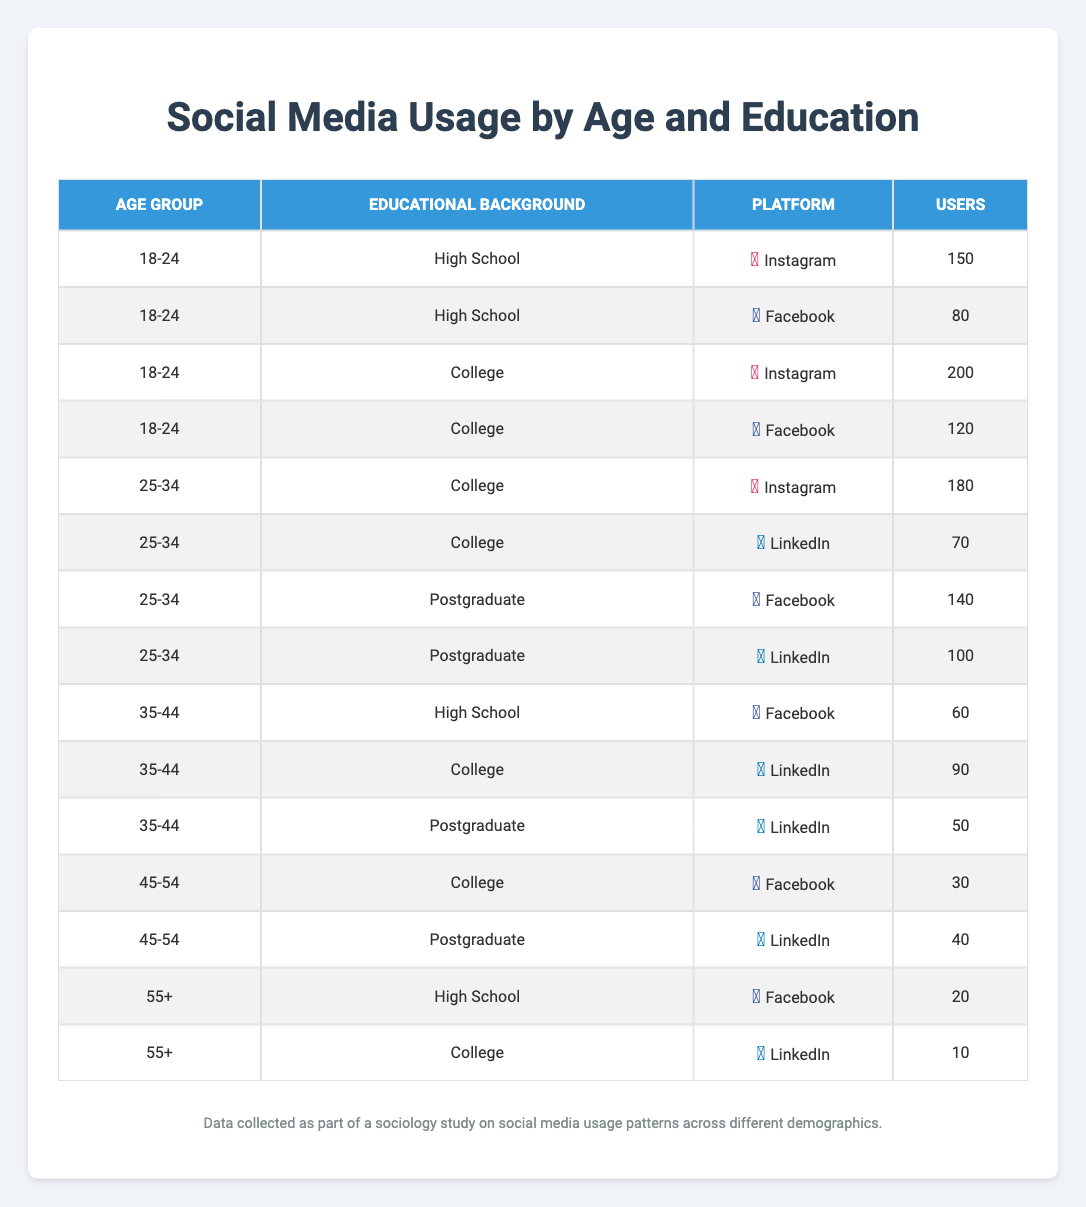What is the number of users aged 25-34 with a College education using Instagram? According to the table, there is a specific entry for the Age Group "25-34" and Educational Background "College" under the Instagram platform. The number of users in that row is 180.
Answer: 180 Which social media platform has the highest number of users in the age group 18-24 with a College education? In the table, for the Age Group "18-24" and Educational Background "College," two platforms are listed: Instagram with 200 users and Facebook with 120 users. Instagram has the highest count of users.
Answer: Instagram How many users aged 35-44 are using LinkedIn, regardless of their educational background? Looking at the rows for the Age Group "35-44," there are two entries for LinkedIn: one for College with 90 users and one for Postgraduate with 50 users. Adding these two amounts (90 + 50) gives 140 users in total.
Answer: 140 Is there any user in the age group 55+ with a College education using Instagram? The table shows that under the Age Group "55+" and Educational Background "College," there is no entry for Instagram, which indicates that there are no users.
Answer: No What is the total number of users across all platforms for the age group of 25-34? The users for the age group "25-34" are Instagram (180), LinkedIn (70), Facebook (140), and LinkedIn (100) again for Postgraduate. Summing these gives 180 + 70 + 140 + 100 = 490 users in total for this age group.
Answer: 490 Which educational background has the most users on Facebook in the 18-24 age group? In the 18-24 age group, the educational backgrounds listed for Facebook are High School (80 users) and College (120 users). The College educational background has more users, hence it's the answer.
Answer: College How many more users aged 25-34 are using Instagram compared to Facebook? For the age group "25-34", Instagram has 180 users while Facebook has 140 users. The difference is 180 - 140 = 40 users, indicating there are more users on Instagram.
Answer: 40 Do users aged 45-54 with a College education use Instagram? The table shows there are no records of users aged 45-54 with a College education on the Instagram platform. Instead, the corresponding educational background shows Facebook with 30 users and Linkedin for Postgraduate.
Answer: No 